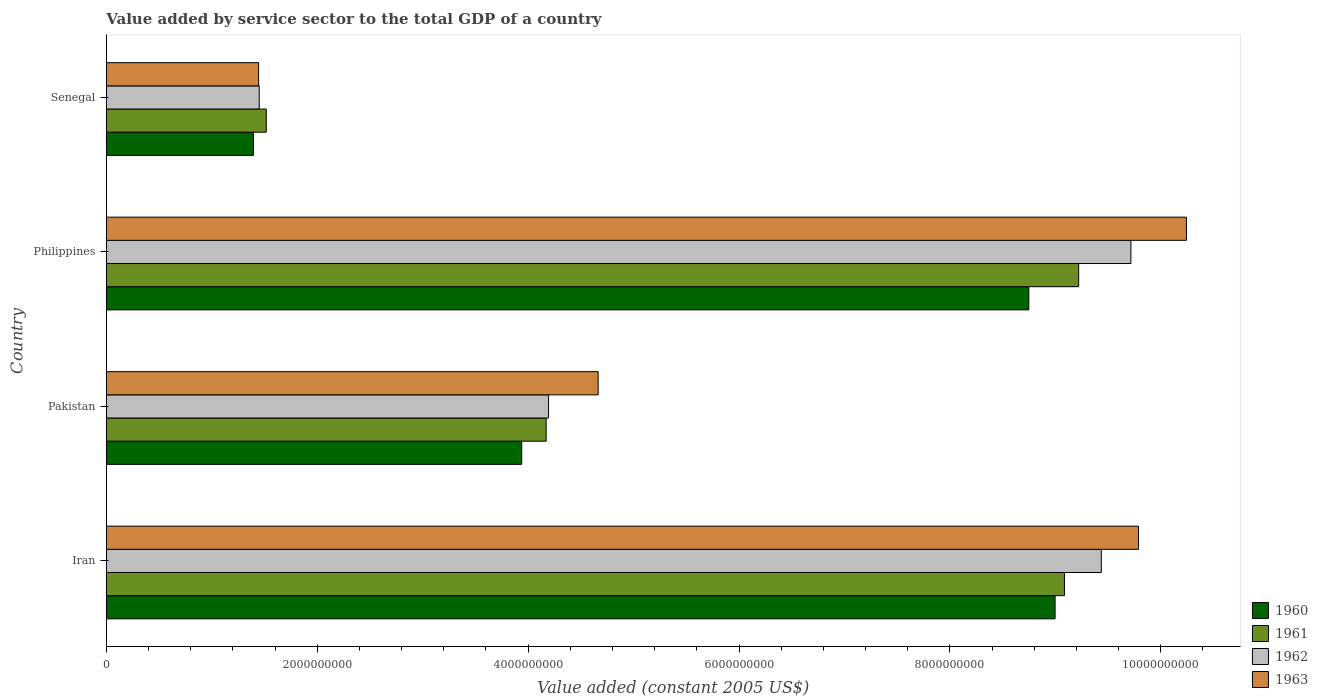Are the number of bars on each tick of the Y-axis equal?
Provide a short and direct response. Yes. How many bars are there on the 1st tick from the top?
Offer a very short reply. 4. What is the label of the 3rd group of bars from the top?
Offer a terse response. Pakistan. What is the value added by service sector in 1960 in Iran?
Offer a terse response. 9.00e+09. Across all countries, what is the maximum value added by service sector in 1962?
Offer a very short reply. 9.72e+09. Across all countries, what is the minimum value added by service sector in 1961?
Provide a short and direct response. 1.52e+09. In which country was the value added by service sector in 1960 maximum?
Provide a short and direct response. Iran. In which country was the value added by service sector in 1962 minimum?
Keep it short and to the point. Senegal. What is the total value added by service sector in 1962 in the graph?
Your response must be concise. 2.48e+1. What is the difference between the value added by service sector in 1960 in Pakistan and that in Senegal?
Your answer should be compact. 2.54e+09. What is the difference between the value added by service sector in 1962 in Pakistan and the value added by service sector in 1961 in Philippines?
Provide a succinct answer. -5.03e+09. What is the average value added by service sector in 1960 per country?
Your response must be concise. 5.77e+09. What is the difference between the value added by service sector in 1962 and value added by service sector in 1963 in Iran?
Offer a very short reply. -3.52e+08. What is the ratio of the value added by service sector in 1962 in Iran to that in Philippines?
Give a very brief answer. 0.97. What is the difference between the highest and the second highest value added by service sector in 1962?
Provide a succinct answer. 2.80e+08. What is the difference between the highest and the lowest value added by service sector in 1961?
Make the answer very short. 7.70e+09. Is it the case that in every country, the sum of the value added by service sector in 1961 and value added by service sector in 1962 is greater than the sum of value added by service sector in 1963 and value added by service sector in 1960?
Provide a short and direct response. No. Is it the case that in every country, the sum of the value added by service sector in 1962 and value added by service sector in 1963 is greater than the value added by service sector in 1960?
Provide a succinct answer. Yes. How many bars are there?
Keep it short and to the point. 16. How many countries are there in the graph?
Ensure brevity in your answer.  4. Does the graph contain grids?
Offer a terse response. No. How many legend labels are there?
Offer a very short reply. 4. What is the title of the graph?
Your answer should be compact. Value added by service sector to the total GDP of a country. Does "1975" appear as one of the legend labels in the graph?
Provide a succinct answer. No. What is the label or title of the X-axis?
Your response must be concise. Value added (constant 2005 US$). What is the Value added (constant 2005 US$) in 1960 in Iran?
Provide a succinct answer. 9.00e+09. What is the Value added (constant 2005 US$) in 1961 in Iran?
Make the answer very short. 9.09e+09. What is the Value added (constant 2005 US$) in 1962 in Iran?
Provide a short and direct response. 9.44e+09. What is the Value added (constant 2005 US$) in 1963 in Iran?
Keep it short and to the point. 9.79e+09. What is the Value added (constant 2005 US$) of 1960 in Pakistan?
Keep it short and to the point. 3.94e+09. What is the Value added (constant 2005 US$) of 1961 in Pakistan?
Offer a terse response. 4.17e+09. What is the Value added (constant 2005 US$) of 1962 in Pakistan?
Keep it short and to the point. 4.19e+09. What is the Value added (constant 2005 US$) in 1963 in Pakistan?
Your answer should be compact. 4.66e+09. What is the Value added (constant 2005 US$) in 1960 in Philippines?
Offer a very short reply. 8.75e+09. What is the Value added (constant 2005 US$) of 1961 in Philippines?
Offer a terse response. 9.22e+09. What is the Value added (constant 2005 US$) in 1962 in Philippines?
Your answer should be very brief. 9.72e+09. What is the Value added (constant 2005 US$) of 1963 in Philippines?
Keep it short and to the point. 1.02e+1. What is the Value added (constant 2005 US$) in 1960 in Senegal?
Keep it short and to the point. 1.39e+09. What is the Value added (constant 2005 US$) of 1961 in Senegal?
Make the answer very short. 1.52e+09. What is the Value added (constant 2005 US$) of 1962 in Senegal?
Ensure brevity in your answer.  1.45e+09. What is the Value added (constant 2005 US$) in 1963 in Senegal?
Keep it short and to the point. 1.44e+09. Across all countries, what is the maximum Value added (constant 2005 US$) of 1960?
Your response must be concise. 9.00e+09. Across all countries, what is the maximum Value added (constant 2005 US$) of 1961?
Provide a short and direct response. 9.22e+09. Across all countries, what is the maximum Value added (constant 2005 US$) of 1962?
Your response must be concise. 9.72e+09. Across all countries, what is the maximum Value added (constant 2005 US$) of 1963?
Provide a succinct answer. 1.02e+1. Across all countries, what is the minimum Value added (constant 2005 US$) of 1960?
Give a very brief answer. 1.39e+09. Across all countries, what is the minimum Value added (constant 2005 US$) of 1961?
Your answer should be compact. 1.52e+09. Across all countries, what is the minimum Value added (constant 2005 US$) of 1962?
Your response must be concise. 1.45e+09. Across all countries, what is the minimum Value added (constant 2005 US$) in 1963?
Ensure brevity in your answer.  1.44e+09. What is the total Value added (constant 2005 US$) in 1960 in the graph?
Provide a short and direct response. 2.31e+1. What is the total Value added (constant 2005 US$) of 1961 in the graph?
Offer a terse response. 2.40e+1. What is the total Value added (constant 2005 US$) of 1962 in the graph?
Your response must be concise. 2.48e+1. What is the total Value added (constant 2005 US$) of 1963 in the graph?
Your answer should be very brief. 2.61e+1. What is the difference between the Value added (constant 2005 US$) of 1960 in Iran and that in Pakistan?
Make the answer very short. 5.06e+09. What is the difference between the Value added (constant 2005 US$) in 1961 in Iran and that in Pakistan?
Ensure brevity in your answer.  4.92e+09. What is the difference between the Value added (constant 2005 US$) in 1962 in Iran and that in Pakistan?
Make the answer very short. 5.24e+09. What is the difference between the Value added (constant 2005 US$) of 1963 in Iran and that in Pakistan?
Offer a very short reply. 5.12e+09. What is the difference between the Value added (constant 2005 US$) in 1960 in Iran and that in Philippines?
Offer a terse response. 2.49e+08. What is the difference between the Value added (constant 2005 US$) in 1961 in Iran and that in Philippines?
Your answer should be very brief. -1.35e+08. What is the difference between the Value added (constant 2005 US$) of 1962 in Iran and that in Philippines?
Ensure brevity in your answer.  -2.80e+08. What is the difference between the Value added (constant 2005 US$) in 1963 in Iran and that in Philippines?
Provide a short and direct response. -4.54e+08. What is the difference between the Value added (constant 2005 US$) in 1960 in Iran and that in Senegal?
Offer a terse response. 7.60e+09. What is the difference between the Value added (constant 2005 US$) of 1961 in Iran and that in Senegal?
Provide a short and direct response. 7.57e+09. What is the difference between the Value added (constant 2005 US$) of 1962 in Iran and that in Senegal?
Your answer should be very brief. 7.99e+09. What is the difference between the Value added (constant 2005 US$) of 1963 in Iran and that in Senegal?
Provide a short and direct response. 8.34e+09. What is the difference between the Value added (constant 2005 US$) of 1960 in Pakistan and that in Philippines?
Keep it short and to the point. -4.81e+09. What is the difference between the Value added (constant 2005 US$) in 1961 in Pakistan and that in Philippines?
Make the answer very short. -5.05e+09. What is the difference between the Value added (constant 2005 US$) in 1962 in Pakistan and that in Philippines?
Your answer should be very brief. -5.52e+09. What is the difference between the Value added (constant 2005 US$) of 1963 in Pakistan and that in Philippines?
Ensure brevity in your answer.  -5.58e+09. What is the difference between the Value added (constant 2005 US$) in 1960 in Pakistan and that in Senegal?
Your response must be concise. 2.54e+09. What is the difference between the Value added (constant 2005 US$) of 1961 in Pakistan and that in Senegal?
Your answer should be compact. 2.65e+09. What is the difference between the Value added (constant 2005 US$) of 1962 in Pakistan and that in Senegal?
Provide a short and direct response. 2.74e+09. What is the difference between the Value added (constant 2005 US$) of 1963 in Pakistan and that in Senegal?
Keep it short and to the point. 3.22e+09. What is the difference between the Value added (constant 2005 US$) of 1960 in Philippines and that in Senegal?
Ensure brevity in your answer.  7.35e+09. What is the difference between the Value added (constant 2005 US$) of 1961 in Philippines and that in Senegal?
Your answer should be very brief. 7.70e+09. What is the difference between the Value added (constant 2005 US$) of 1962 in Philippines and that in Senegal?
Offer a terse response. 8.27e+09. What is the difference between the Value added (constant 2005 US$) in 1963 in Philippines and that in Senegal?
Make the answer very short. 8.80e+09. What is the difference between the Value added (constant 2005 US$) in 1960 in Iran and the Value added (constant 2005 US$) in 1961 in Pakistan?
Provide a succinct answer. 4.83e+09. What is the difference between the Value added (constant 2005 US$) of 1960 in Iran and the Value added (constant 2005 US$) of 1962 in Pakistan?
Provide a succinct answer. 4.80e+09. What is the difference between the Value added (constant 2005 US$) in 1960 in Iran and the Value added (constant 2005 US$) in 1963 in Pakistan?
Offer a terse response. 4.33e+09. What is the difference between the Value added (constant 2005 US$) of 1961 in Iran and the Value added (constant 2005 US$) of 1962 in Pakistan?
Keep it short and to the point. 4.89e+09. What is the difference between the Value added (constant 2005 US$) of 1961 in Iran and the Value added (constant 2005 US$) of 1963 in Pakistan?
Keep it short and to the point. 4.42e+09. What is the difference between the Value added (constant 2005 US$) in 1962 in Iran and the Value added (constant 2005 US$) in 1963 in Pakistan?
Offer a very short reply. 4.77e+09. What is the difference between the Value added (constant 2005 US$) of 1960 in Iran and the Value added (constant 2005 US$) of 1961 in Philippines?
Offer a terse response. -2.24e+08. What is the difference between the Value added (constant 2005 US$) in 1960 in Iran and the Value added (constant 2005 US$) in 1962 in Philippines?
Provide a short and direct response. -7.19e+08. What is the difference between the Value added (constant 2005 US$) in 1960 in Iran and the Value added (constant 2005 US$) in 1963 in Philippines?
Your answer should be compact. -1.25e+09. What is the difference between the Value added (constant 2005 US$) in 1961 in Iran and the Value added (constant 2005 US$) in 1962 in Philippines?
Keep it short and to the point. -6.30e+08. What is the difference between the Value added (constant 2005 US$) of 1961 in Iran and the Value added (constant 2005 US$) of 1963 in Philippines?
Your answer should be very brief. -1.16e+09. What is the difference between the Value added (constant 2005 US$) of 1962 in Iran and the Value added (constant 2005 US$) of 1963 in Philippines?
Offer a very short reply. -8.07e+08. What is the difference between the Value added (constant 2005 US$) of 1960 in Iran and the Value added (constant 2005 US$) of 1961 in Senegal?
Provide a short and direct response. 7.48e+09. What is the difference between the Value added (constant 2005 US$) in 1960 in Iran and the Value added (constant 2005 US$) in 1962 in Senegal?
Ensure brevity in your answer.  7.55e+09. What is the difference between the Value added (constant 2005 US$) in 1960 in Iran and the Value added (constant 2005 US$) in 1963 in Senegal?
Offer a very short reply. 7.55e+09. What is the difference between the Value added (constant 2005 US$) in 1961 in Iran and the Value added (constant 2005 US$) in 1962 in Senegal?
Offer a terse response. 7.64e+09. What is the difference between the Value added (constant 2005 US$) in 1961 in Iran and the Value added (constant 2005 US$) in 1963 in Senegal?
Give a very brief answer. 7.64e+09. What is the difference between the Value added (constant 2005 US$) of 1962 in Iran and the Value added (constant 2005 US$) of 1963 in Senegal?
Give a very brief answer. 7.99e+09. What is the difference between the Value added (constant 2005 US$) in 1960 in Pakistan and the Value added (constant 2005 US$) in 1961 in Philippines?
Offer a very short reply. -5.28e+09. What is the difference between the Value added (constant 2005 US$) in 1960 in Pakistan and the Value added (constant 2005 US$) in 1962 in Philippines?
Your response must be concise. -5.78e+09. What is the difference between the Value added (constant 2005 US$) in 1960 in Pakistan and the Value added (constant 2005 US$) in 1963 in Philippines?
Give a very brief answer. -6.30e+09. What is the difference between the Value added (constant 2005 US$) in 1961 in Pakistan and the Value added (constant 2005 US$) in 1962 in Philippines?
Offer a terse response. -5.55e+09. What is the difference between the Value added (constant 2005 US$) in 1961 in Pakistan and the Value added (constant 2005 US$) in 1963 in Philippines?
Your answer should be compact. -6.07e+09. What is the difference between the Value added (constant 2005 US$) in 1962 in Pakistan and the Value added (constant 2005 US$) in 1963 in Philippines?
Ensure brevity in your answer.  -6.05e+09. What is the difference between the Value added (constant 2005 US$) in 1960 in Pakistan and the Value added (constant 2005 US$) in 1961 in Senegal?
Keep it short and to the point. 2.42e+09. What is the difference between the Value added (constant 2005 US$) in 1960 in Pakistan and the Value added (constant 2005 US$) in 1962 in Senegal?
Offer a very short reply. 2.49e+09. What is the difference between the Value added (constant 2005 US$) in 1960 in Pakistan and the Value added (constant 2005 US$) in 1963 in Senegal?
Your answer should be compact. 2.49e+09. What is the difference between the Value added (constant 2005 US$) of 1961 in Pakistan and the Value added (constant 2005 US$) of 1962 in Senegal?
Keep it short and to the point. 2.72e+09. What is the difference between the Value added (constant 2005 US$) in 1961 in Pakistan and the Value added (constant 2005 US$) in 1963 in Senegal?
Keep it short and to the point. 2.73e+09. What is the difference between the Value added (constant 2005 US$) in 1962 in Pakistan and the Value added (constant 2005 US$) in 1963 in Senegal?
Make the answer very short. 2.75e+09. What is the difference between the Value added (constant 2005 US$) of 1960 in Philippines and the Value added (constant 2005 US$) of 1961 in Senegal?
Your answer should be compact. 7.23e+09. What is the difference between the Value added (constant 2005 US$) of 1960 in Philippines and the Value added (constant 2005 US$) of 1962 in Senegal?
Provide a succinct answer. 7.30e+09. What is the difference between the Value added (constant 2005 US$) in 1960 in Philippines and the Value added (constant 2005 US$) in 1963 in Senegal?
Keep it short and to the point. 7.30e+09. What is the difference between the Value added (constant 2005 US$) of 1961 in Philippines and the Value added (constant 2005 US$) of 1962 in Senegal?
Offer a very short reply. 7.77e+09. What is the difference between the Value added (constant 2005 US$) of 1961 in Philippines and the Value added (constant 2005 US$) of 1963 in Senegal?
Provide a short and direct response. 7.78e+09. What is the difference between the Value added (constant 2005 US$) of 1962 in Philippines and the Value added (constant 2005 US$) of 1963 in Senegal?
Keep it short and to the point. 8.27e+09. What is the average Value added (constant 2005 US$) in 1960 per country?
Provide a short and direct response. 5.77e+09. What is the average Value added (constant 2005 US$) in 1961 per country?
Provide a succinct answer. 6.00e+09. What is the average Value added (constant 2005 US$) in 1962 per country?
Make the answer very short. 6.20e+09. What is the average Value added (constant 2005 US$) in 1963 per country?
Keep it short and to the point. 6.53e+09. What is the difference between the Value added (constant 2005 US$) of 1960 and Value added (constant 2005 US$) of 1961 in Iran?
Your answer should be compact. -8.88e+07. What is the difference between the Value added (constant 2005 US$) of 1960 and Value added (constant 2005 US$) of 1962 in Iran?
Provide a succinct answer. -4.39e+08. What is the difference between the Value added (constant 2005 US$) in 1960 and Value added (constant 2005 US$) in 1963 in Iran?
Give a very brief answer. -7.91e+08. What is the difference between the Value added (constant 2005 US$) in 1961 and Value added (constant 2005 US$) in 1962 in Iran?
Keep it short and to the point. -3.50e+08. What is the difference between the Value added (constant 2005 US$) of 1961 and Value added (constant 2005 US$) of 1963 in Iran?
Provide a succinct answer. -7.02e+08. What is the difference between the Value added (constant 2005 US$) of 1962 and Value added (constant 2005 US$) of 1963 in Iran?
Offer a very short reply. -3.52e+08. What is the difference between the Value added (constant 2005 US$) of 1960 and Value added (constant 2005 US$) of 1961 in Pakistan?
Your answer should be very brief. -2.32e+08. What is the difference between the Value added (constant 2005 US$) in 1960 and Value added (constant 2005 US$) in 1962 in Pakistan?
Offer a very short reply. -2.54e+08. What is the difference between the Value added (constant 2005 US$) of 1960 and Value added (constant 2005 US$) of 1963 in Pakistan?
Your answer should be very brief. -7.25e+08. What is the difference between the Value added (constant 2005 US$) in 1961 and Value added (constant 2005 US$) in 1962 in Pakistan?
Offer a very short reply. -2.26e+07. What is the difference between the Value added (constant 2005 US$) of 1961 and Value added (constant 2005 US$) of 1963 in Pakistan?
Give a very brief answer. -4.93e+08. What is the difference between the Value added (constant 2005 US$) of 1962 and Value added (constant 2005 US$) of 1963 in Pakistan?
Your answer should be compact. -4.71e+08. What is the difference between the Value added (constant 2005 US$) in 1960 and Value added (constant 2005 US$) in 1961 in Philippines?
Keep it short and to the point. -4.73e+08. What is the difference between the Value added (constant 2005 US$) of 1960 and Value added (constant 2005 US$) of 1962 in Philippines?
Your response must be concise. -9.68e+08. What is the difference between the Value added (constant 2005 US$) of 1960 and Value added (constant 2005 US$) of 1963 in Philippines?
Offer a terse response. -1.49e+09. What is the difference between the Value added (constant 2005 US$) in 1961 and Value added (constant 2005 US$) in 1962 in Philippines?
Provide a short and direct response. -4.95e+08. What is the difference between the Value added (constant 2005 US$) in 1961 and Value added (constant 2005 US$) in 1963 in Philippines?
Your answer should be very brief. -1.02e+09. What is the difference between the Value added (constant 2005 US$) in 1962 and Value added (constant 2005 US$) in 1963 in Philippines?
Give a very brief answer. -5.27e+08. What is the difference between the Value added (constant 2005 US$) of 1960 and Value added (constant 2005 US$) of 1961 in Senegal?
Ensure brevity in your answer.  -1.22e+08. What is the difference between the Value added (constant 2005 US$) of 1960 and Value added (constant 2005 US$) of 1962 in Senegal?
Offer a terse response. -5.52e+07. What is the difference between the Value added (constant 2005 US$) in 1960 and Value added (constant 2005 US$) in 1963 in Senegal?
Your answer should be very brief. -4.94e+07. What is the difference between the Value added (constant 2005 US$) in 1961 and Value added (constant 2005 US$) in 1962 in Senegal?
Your response must be concise. 6.67e+07. What is the difference between the Value added (constant 2005 US$) of 1961 and Value added (constant 2005 US$) of 1963 in Senegal?
Give a very brief answer. 7.25e+07. What is the difference between the Value added (constant 2005 US$) in 1962 and Value added (constant 2005 US$) in 1963 in Senegal?
Offer a very short reply. 5.77e+06. What is the ratio of the Value added (constant 2005 US$) of 1960 in Iran to that in Pakistan?
Make the answer very short. 2.28. What is the ratio of the Value added (constant 2005 US$) in 1961 in Iran to that in Pakistan?
Your response must be concise. 2.18. What is the ratio of the Value added (constant 2005 US$) of 1962 in Iran to that in Pakistan?
Offer a terse response. 2.25. What is the ratio of the Value added (constant 2005 US$) in 1963 in Iran to that in Pakistan?
Provide a short and direct response. 2.1. What is the ratio of the Value added (constant 2005 US$) of 1960 in Iran to that in Philippines?
Give a very brief answer. 1.03. What is the ratio of the Value added (constant 2005 US$) of 1961 in Iran to that in Philippines?
Give a very brief answer. 0.99. What is the ratio of the Value added (constant 2005 US$) of 1962 in Iran to that in Philippines?
Give a very brief answer. 0.97. What is the ratio of the Value added (constant 2005 US$) in 1963 in Iran to that in Philippines?
Provide a short and direct response. 0.96. What is the ratio of the Value added (constant 2005 US$) of 1960 in Iran to that in Senegal?
Your answer should be compact. 6.45. What is the ratio of the Value added (constant 2005 US$) of 1961 in Iran to that in Senegal?
Offer a very short reply. 5.99. What is the ratio of the Value added (constant 2005 US$) in 1962 in Iran to that in Senegal?
Keep it short and to the point. 6.51. What is the ratio of the Value added (constant 2005 US$) in 1963 in Iran to that in Senegal?
Ensure brevity in your answer.  6.78. What is the ratio of the Value added (constant 2005 US$) in 1960 in Pakistan to that in Philippines?
Ensure brevity in your answer.  0.45. What is the ratio of the Value added (constant 2005 US$) in 1961 in Pakistan to that in Philippines?
Give a very brief answer. 0.45. What is the ratio of the Value added (constant 2005 US$) of 1962 in Pakistan to that in Philippines?
Your answer should be compact. 0.43. What is the ratio of the Value added (constant 2005 US$) in 1963 in Pakistan to that in Philippines?
Give a very brief answer. 0.46. What is the ratio of the Value added (constant 2005 US$) of 1960 in Pakistan to that in Senegal?
Your answer should be very brief. 2.82. What is the ratio of the Value added (constant 2005 US$) in 1961 in Pakistan to that in Senegal?
Ensure brevity in your answer.  2.75. What is the ratio of the Value added (constant 2005 US$) in 1962 in Pakistan to that in Senegal?
Give a very brief answer. 2.89. What is the ratio of the Value added (constant 2005 US$) in 1963 in Pakistan to that in Senegal?
Your answer should be compact. 3.23. What is the ratio of the Value added (constant 2005 US$) of 1960 in Philippines to that in Senegal?
Provide a short and direct response. 6.27. What is the ratio of the Value added (constant 2005 US$) in 1961 in Philippines to that in Senegal?
Keep it short and to the point. 6.08. What is the ratio of the Value added (constant 2005 US$) in 1962 in Philippines to that in Senegal?
Your answer should be compact. 6.7. What is the ratio of the Value added (constant 2005 US$) of 1963 in Philippines to that in Senegal?
Offer a very short reply. 7.09. What is the difference between the highest and the second highest Value added (constant 2005 US$) in 1960?
Provide a succinct answer. 2.49e+08. What is the difference between the highest and the second highest Value added (constant 2005 US$) of 1961?
Offer a terse response. 1.35e+08. What is the difference between the highest and the second highest Value added (constant 2005 US$) in 1962?
Offer a very short reply. 2.80e+08. What is the difference between the highest and the second highest Value added (constant 2005 US$) in 1963?
Offer a very short reply. 4.54e+08. What is the difference between the highest and the lowest Value added (constant 2005 US$) of 1960?
Give a very brief answer. 7.60e+09. What is the difference between the highest and the lowest Value added (constant 2005 US$) of 1961?
Provide a succinct answer. 7.70e+09. What is the difference between the highest and the lowest Value added (constant 2005 US$) in 1962?
Make the answer very short. 8.27e+09. What is the difference between the highest and the lowest Value added (constant 2005 US$) of 1963?
Make the answer very short. 8.80e+09. 